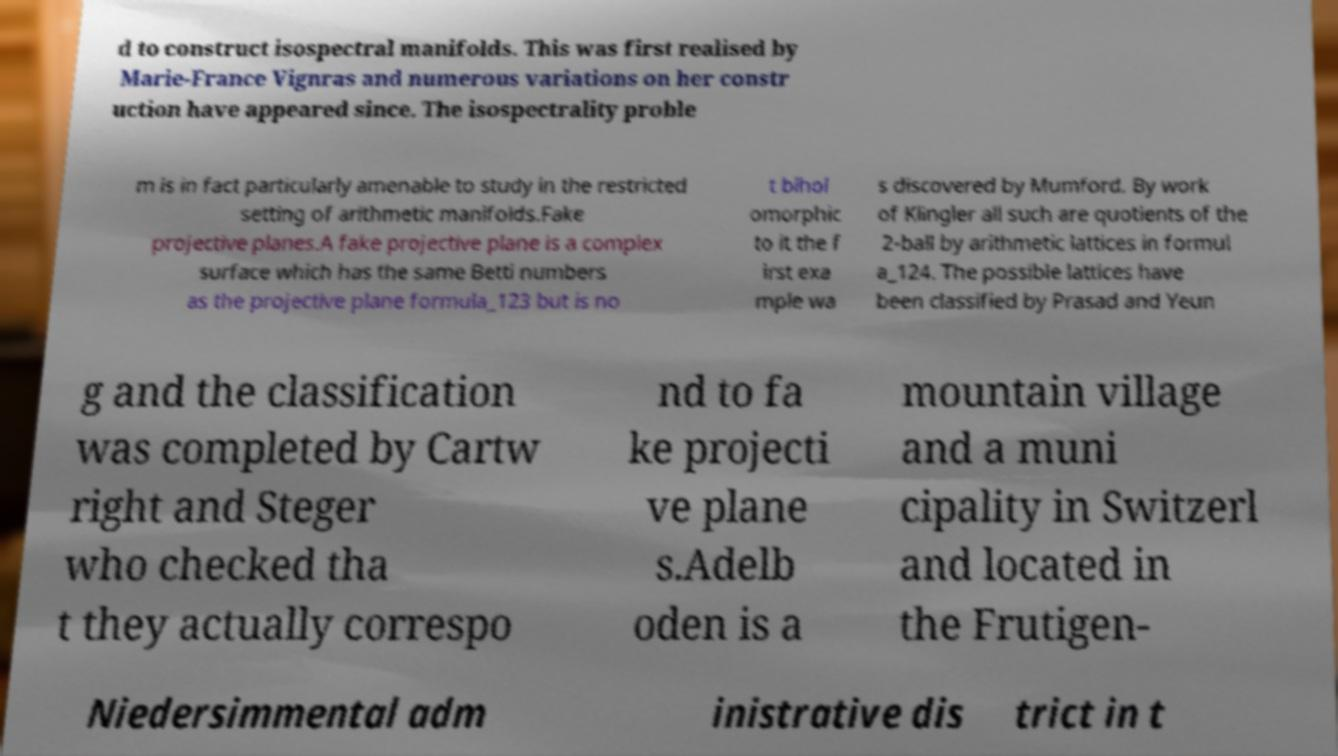For documentation purposes, I need the text within this image transcribed. Could you provide that? d to construct isospectral manifolds. This was first realised by Marie-France Vignras and numerous variations on her constr uction have appeared since. The isospectrality proble m is in fact particularly amenable to study in the restricted setting of arithmetic manifolds.Fake projective planes.A fake projective plane is a complex surface which has the same Betti numbers as the projective plane formula_123 but is no t bihol omorphic to it the f irst exa mple wa s discovered by Mumford. By work of Klingler all such are quotients of the 2-ball by arithmetic lattices in formul a_124. The possible lattices have been classified by Prasad and Yeun g and the classification was completed by Cartw right and Steger who checked tha t they actually correspo nd to fa ke projecti ve plane s.Adelb oden is a mountain village and a muni cipality in Switzerl and located in the Frutigen- Niedersimmental adm inistrative dis trict in t 